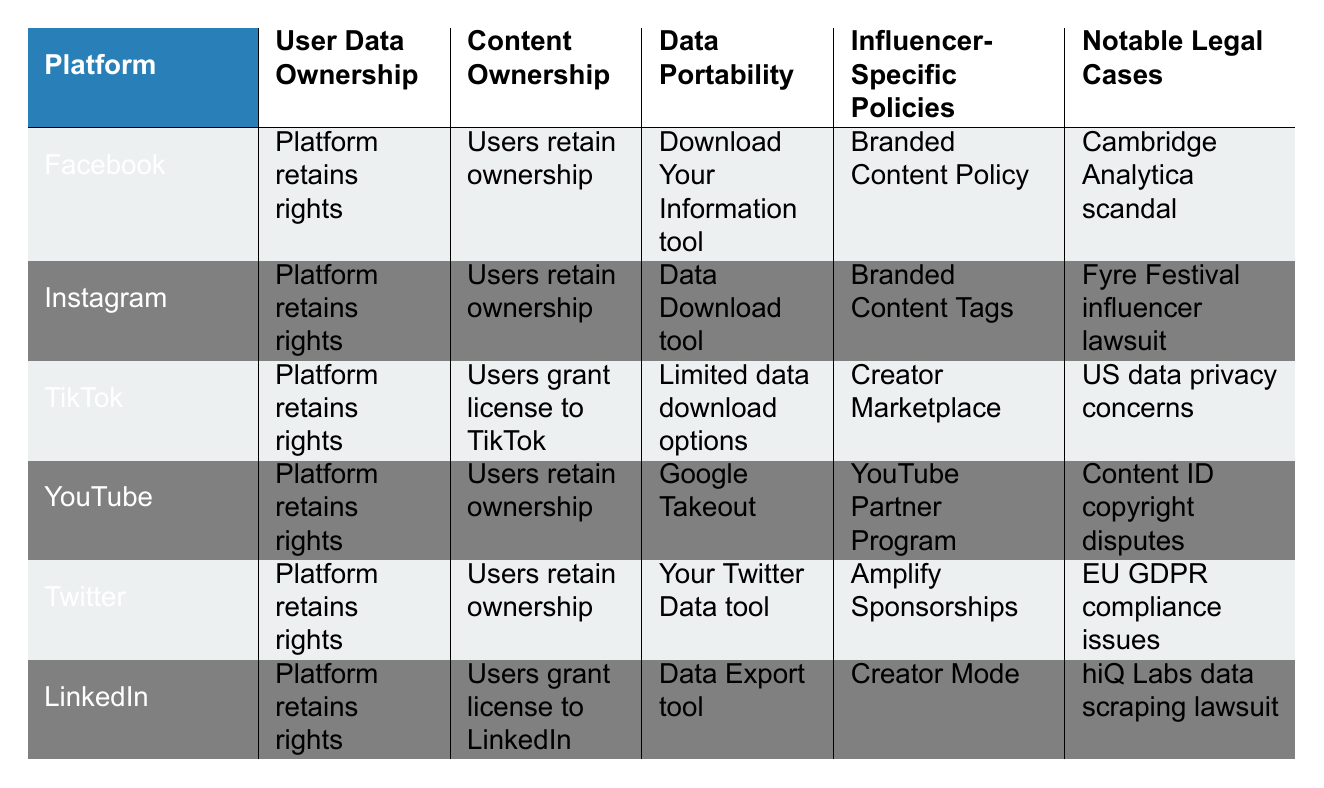What data portability tool does Facebook provide? Facebook offers the "Download Your Information" tool for data portability, as indicated in the table under the Data Portability column for Facebook.
Answer: Download Your Information tool Which platforms allow users to retain ownership of their content? By analyzing the Content Ownership column, we can see that Facebook, Instagram, YouTube, and Twitter all indicate that users retain ownership of their content.
Answer: Facebook, Instagram, YouTube, Twitter Is there any platform that requires users to grant a license for their content? The table shows that both TikTok and LinkedIn require users to grant a license for their content. TikTok specifies that users grant a license to TikTok, and LinkedIn specifies that users grant a license to LinkedIn.
Answer: TikTok, LinkedIn What is the notable legal case associated with TikTok? Referring to the Notable Legal Cases column, TikTok's notable case pertains to US data privacy concerns.
Answer: US data privacy concerns Which platform offers limited options for data portability? In the Data Portability column, TikTok indicates that it has limited data download options, distinguishing it from other platforms with more comprehensive tools.
Answer: TikTok How many platforms allow users to download their data? By examining the Data Portability column, we can count that five platforms (Facebook, Instagram, YouTube, Twitter, and LinkedIn) offer a data download tool; only TikTok does not.
Answer: 5 Is there a specific policy for influencers on Instagram? The table notes that Instagram has "Branded Content Tags" as its influencer-specific policy, indicating a dedicated approach for influencers.
Answer: Branded Content Tags What common feature do most platforms share regarding user data ownership? All platforms except for TikTok and LinkedIn retain rights to user data, as seen in the User Data Ownership column; thus, platforms like Facebook, Instagram, YouTube, and Twitter universally maintain ownership.
Answer: Platform retains rights (4 instances) Can you identify how many platforms have been involved in notable legal cases? Five platforms list notable legal cases in the table, as all but TikTok specify a noteworthy legal context, indicating a common legal scrutiny.
Answer: 5 What are the influencer-specific policies mentioned for the platforms combined? By reviewing the Influencer-Specific Policies column, the policies across the platforms include: "Branded Content Policy" (Facebook), "Branded Content Tags" (Instagram), "Creator Marketplace" (TikTok), "YouTube Partner Program" (YouTube), "Amplify Sponsorships" (Twitter), and "Creator Mode" (LinkedIn).
Answer: 6 policies in total 